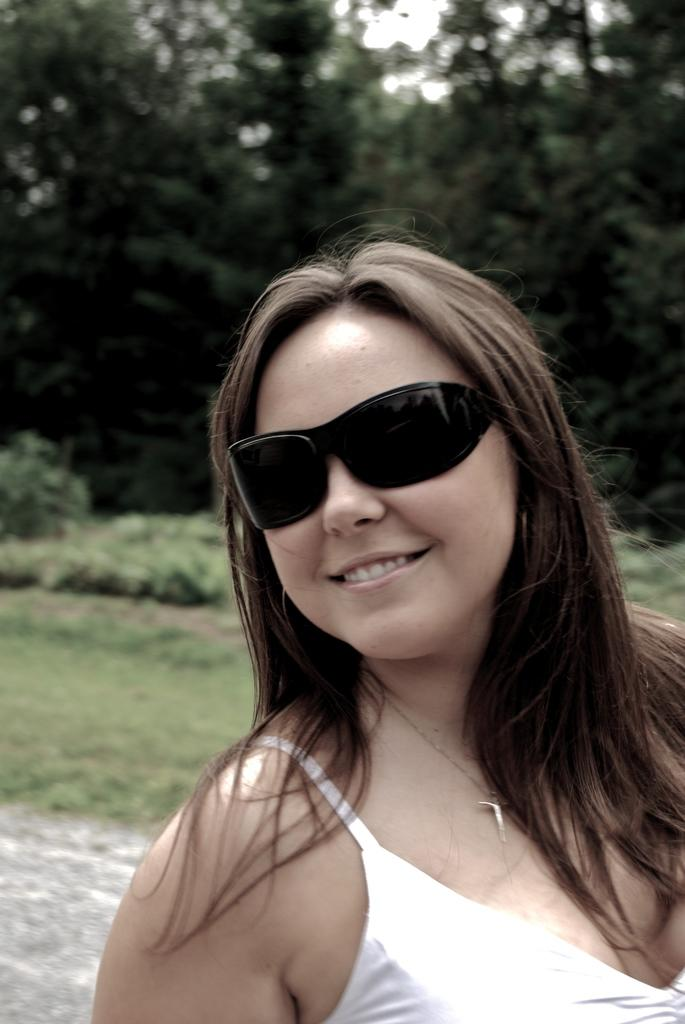Who is present in the image? There is a woman in the image. What is the woman wearing on her face? The woman is wearing goggles. What type of clothing is the woman wearing? The woman is wearing clothes. What can be seen in the background of the image? There are trees in the image. What type of bead is being used for acoustics in the image? There is no bead or mention of acoustics in the image. 